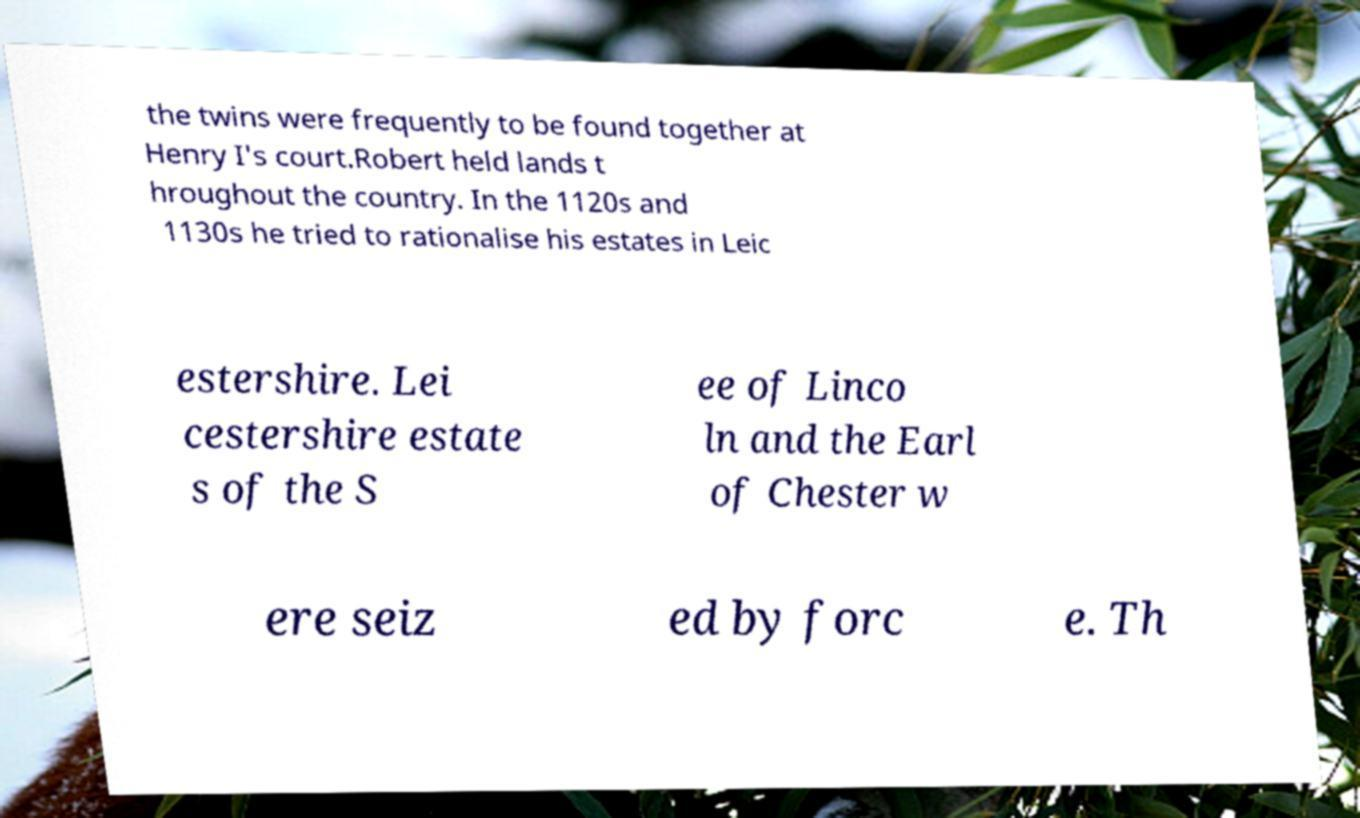Please identify and transcribe the text found in this image. the twins were frequently to be found together at Henry I's court.Robert held lands t hroughout the country. In the 1120s and 1130s he tried to rationalise his estates in Leic estershire. Lei cestershire estate s of the S ee of Linco ln and the Earl of Chester w ere seiz ed by forc e. Th 